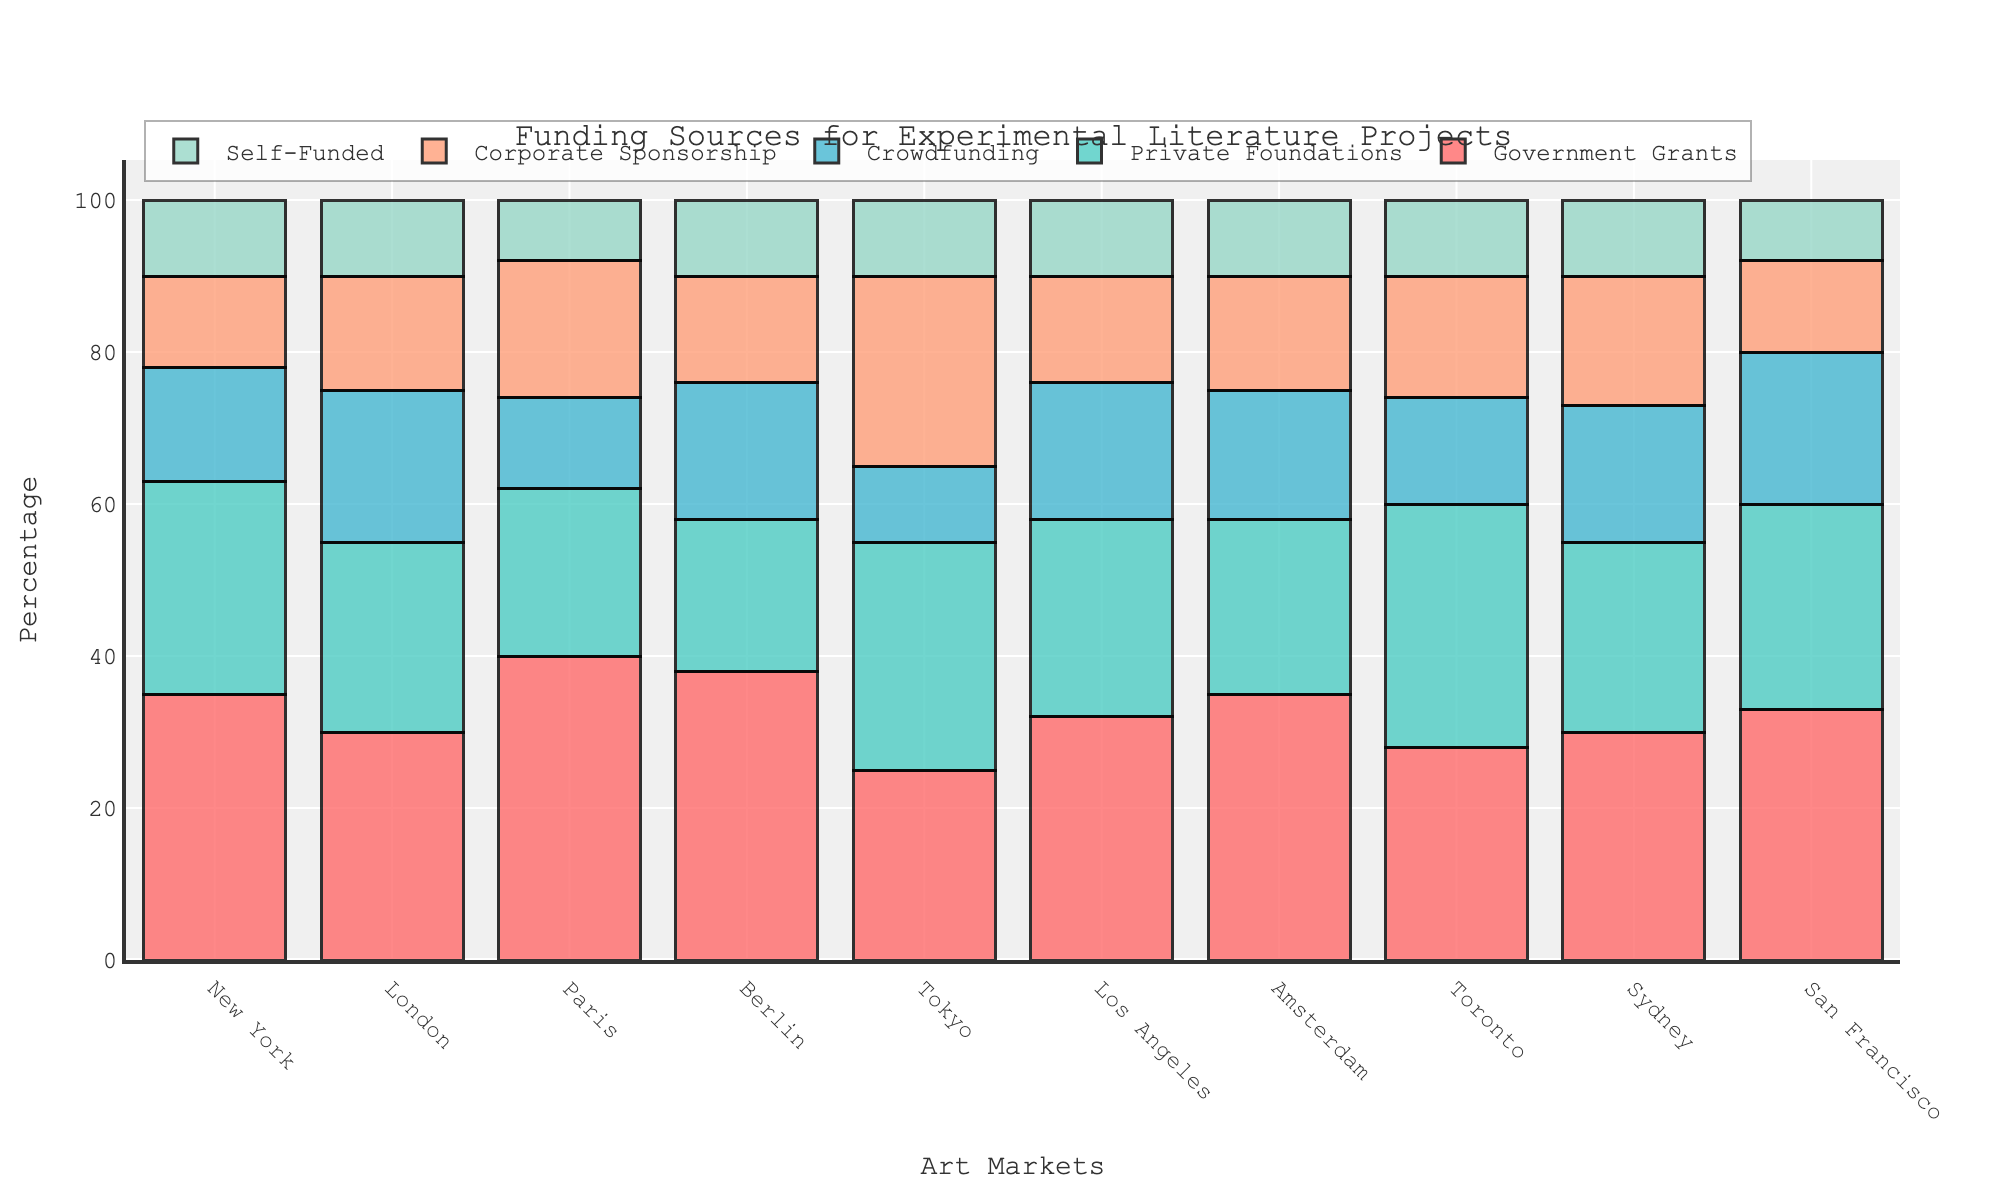Which city received the highest amount of government grants? From the chart, the city with the tallest bar in the "Government Grants" section is Paris.
Answer: Paris Which city has received equal amounts of funding from crowdfunding and corporate sponsorships? By checking each city, it's evident that in Tokyo, both crowdfunding and corporate sponsorships are at equal percentages, specifically 25%.
Answer: Tokyo What's the total percentage of self-funding across all cities? Adding up the percentages of self-funding for all the cities: 10+10+8+10+10+10+10+10+10+8 = 96.
Answer: 96 Which city has the smallest contribution from private foundations? Observing the bars for "Private Foundations", Paris has the smallest contribution with a 22% funding rate.
Answer: Paris Compare New York and Tokyo. Which city has more diversity in its funding sources and why? Each city’s funding source percentages need to be compared for variability: - New York: 35, 28, 15, 12, 10 Tokyo: 25, 30, 10, 25, 10 Tokyo has a wider spread in percentages, indicating more diversity in its funding sources.
Answer: Tokyo How does the height of the corporate sponsorship bar for Paris compare to that of Berlin? Comparing the bars of corporate sponsorship for Paris (18%) and Berlin (14%), Paris has a taller bar indicating more funding.
Answer: Paris Which city has the highest bar across all funding sources and for which source? Paris stands out with the highest bar in "Government Grants" at 40%.
Answer: Paris (Government Grants) Is the height of the crowdfunding bars for Amsterdam and San Francisco equal? Observing the chart, the crowdfunding bars for both Amsterdam and San Francisco are at 17% and 20%, respectively, which are not equal.
Answer: No What's the average government grant funding across all cities? Sum of government grant percentages: 35+30+40+38+25+32+35+28+30+33 = 326. The average is 326/10 = 32.6.
Answer: 32.6 Which city has the most balanced distribution of its funding sources? By visually inspecting the evenness of bar heights for each city, New York appears to have the most balanced distribution with its bars quite similar in height compared to others.
Answer: New York 